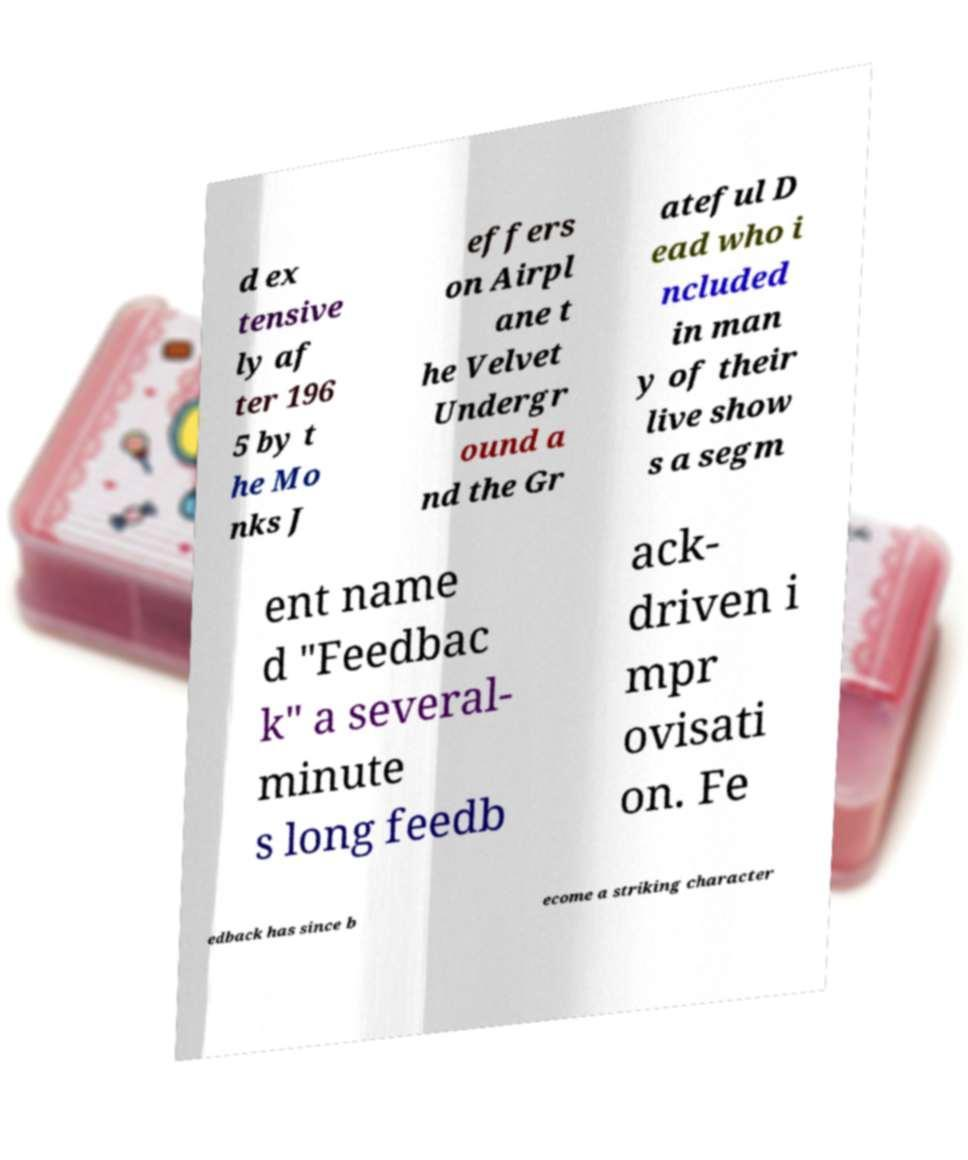Please read and relay the text visible in this image. What does it say? d ex tensive ly af ter 196 5 by t he Mo nks J effers on Airpl ane t he Velvet Undergr ound a nd the Gr ateful D ead who i ncluded in man y of their live show s a segm ent name d "Feedbac k" a several- minute s long feedb ack- driven i mpr ovisati on. Fe edback has since b ecome a striking character 